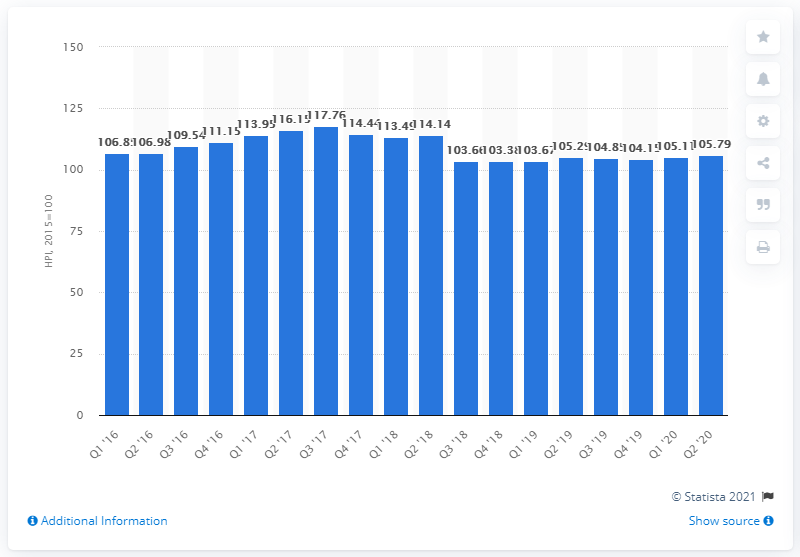Outline some significant characteristics in this image. In the quarter ending September 2020, the house price index in Sweden was 105.79. 